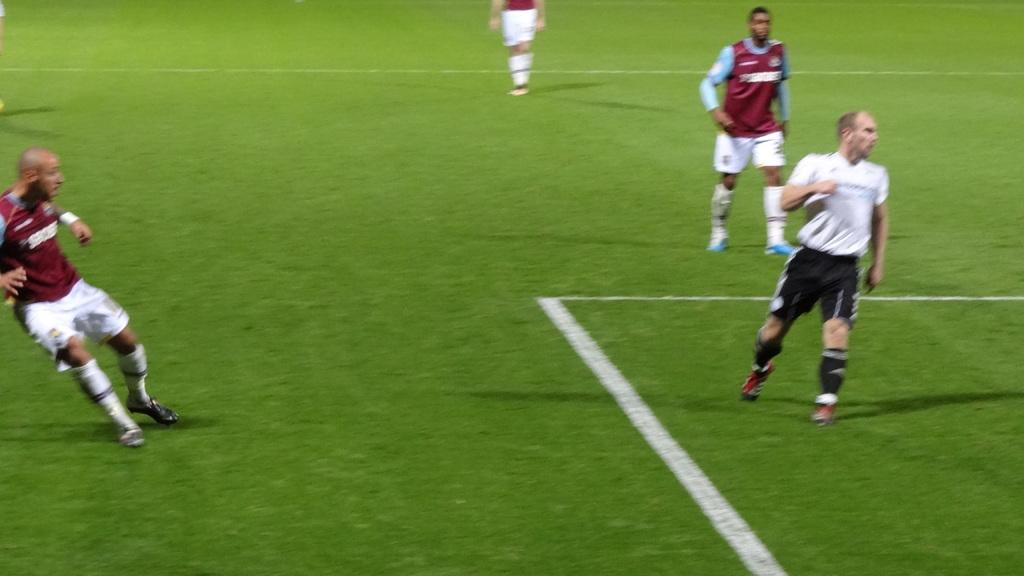Who or what is present in the image? There are people in the image. What type of clothing are the people wearing? The people are wearing shorts and shoes. What can be seen on the floor in the image? There are white lines on the floor. What type of machine is being used by the people in the image? There is no machine present in the image; the people are simply wearing shorts and shoes. Can you tell me how many holes are visible in the image? There are no holes visible in the image. 